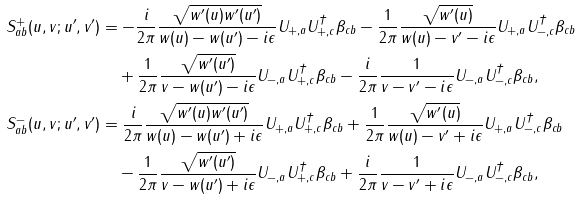Convert formula to latex. <formula><loc_0><loc_0><loc_500><loc_500>S _ { a b } ^ { + } ( u , v ; u ^ { \prime } , v ^ { \prime } ) & = - \frac { i } { 2 \pi } \frac { \sqrt { w ^ { \prime } ( u ) w ^ { \prime } ( u ^ { \prime } ) } } { w ( u ) - w ( u ^ { \prime } ) - i \epsilon } U _ { + , a } U _ { + , c } ^ { \dagger } \beta _ { c b } - \frac { 1 } { 2 \pi } \frac { \sqrt { w ^ { \prime } ( u ) } } { w ( u ) - v ^ { \prime } - i \epsilon } U _ { + , a } U _ { - , c } ^ { \dagger } \beta _ { c b } \\ & \quad + \frac { 1 } { 2 \pi } \frac { \sqrt { w ^ { \prime } ( u ^ { \prime } ) } } { v - w ( u ^ { \prime } ) - i \epsilon } U _ { - , a } U _ { + , c } ^ { \dagger } \beta _ { c b } - \frac { i } { 2 \pi } \frac { 1 } { v - v ^ { \prime } - i \epsilon } U _ { - , a } U _ { - , c } ^ { \dagger } \beta _ { c b } , \\ S _ { a b } ^ { - } ( u , v ; u ^ { \prime } , v ^ { \prime } ) & = \frac { i } { 2 \pi } \frac { \sqrt { w ^ { \prime } ( u ) w ^ { \prime } ( u ^ { \prime } ) } } { w ( u ) - w ( u ^ { \prime } ) + i \epsilon } U _ { + , a } U _ { + , c } ^ { \dagger } \beta _ { c b } + \frac { 1 } { 2 \pi } \frac { \sqrt { w ^ { \prime } ( u ) } } { w ( u ) - v ^ { \prime } + i \epsilon } U _ { + , a } U _ { - , c } ^ { \dagger } \beta _ { c b } \\ & \quad - \frac { 1 } { 2 \pi } \frac { \sqrt { w ^ { \prime } ( u ^ { \prime } ) } } { v - w ( u ^ { \prime } ) + i \epsilon } U _ { - , a } U _ { + , c } ^ { \dagger } \beta _ { c b } + \frac { i } { 2 \pi } \frac { 1 } { v - v ^ { \prime } + i \epsilon } U _ { - , a } U _ { - , c } ^ { \dagger } \beta _ { c b } ,</formula> 